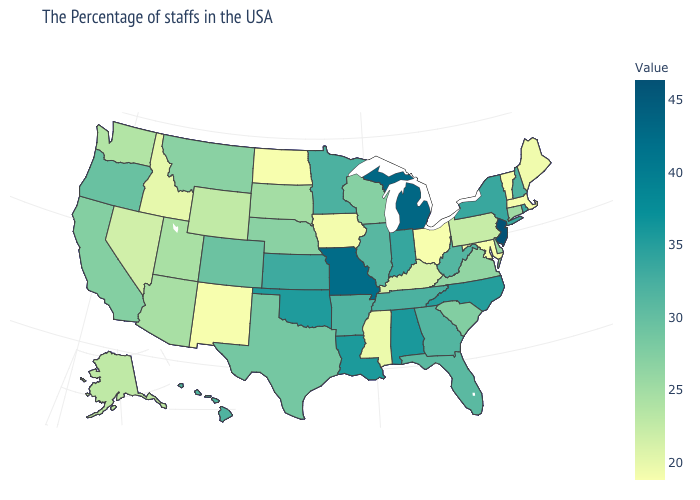Among the states that border Indiana , does Kentucky have the lowest value?
Be succinct. No. Among the states that border Georgia , does Alabama have the highest value?
Answer briefly. Yes. Does Alabama have the lowest value in the USA?
Give a very brief answer. No. Does Tennessee have a higher value than New Mexico?
Short answer required. Yes. 